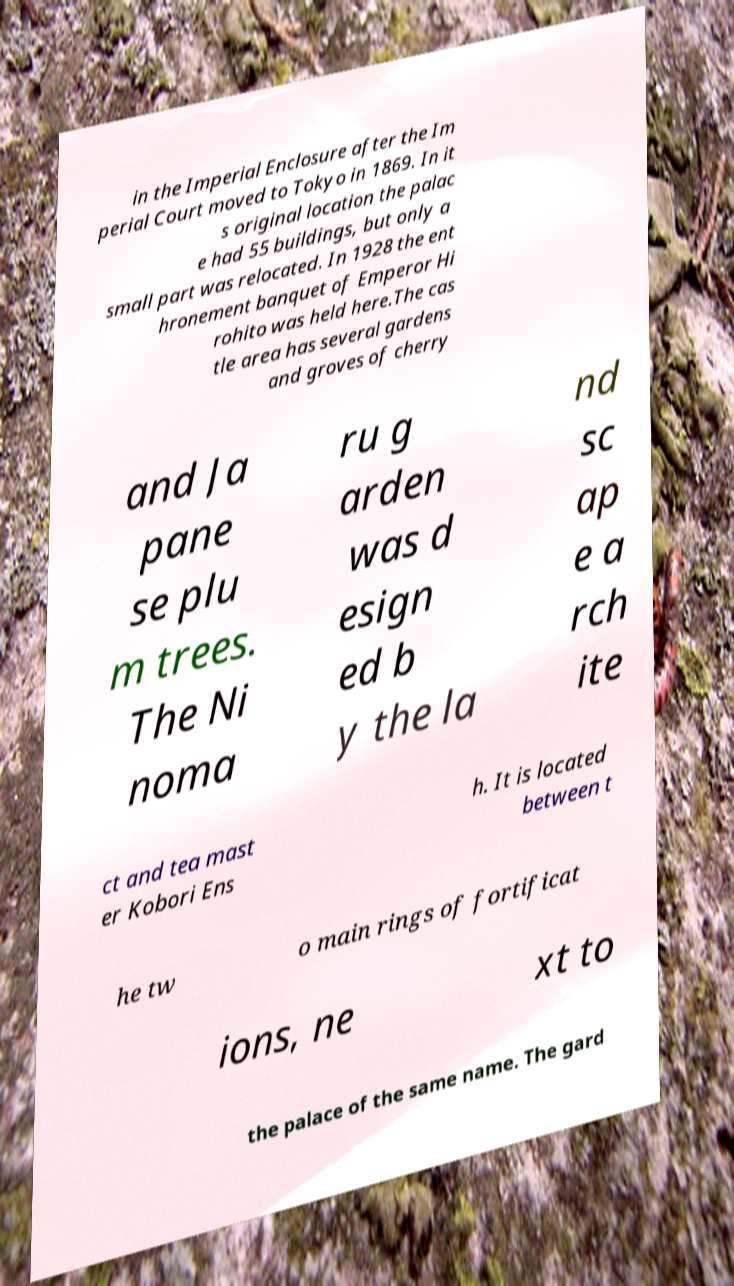For documentation purposes, I need the text within this image transcribed. Could you provide that? in the Imperial Enclosure after the Im perial Court moved to Tokyo in 1869. In it s original location the palac e had 55 buildings, but only a small part was relocated. In 1928 the ent hronement banquet of Emperor Hi rohito was held here.The cas tle area has several gardens and groves of cherry and Ja pane se plu m trees. The Ni noma ru g arden was d esign ed b y the la nd sc ap e a rch ite ct and tea mast er Kobori Ens h. It is located between t he tw o main rings of fortificat ions, ne xt to the palace of the same name. The gard 